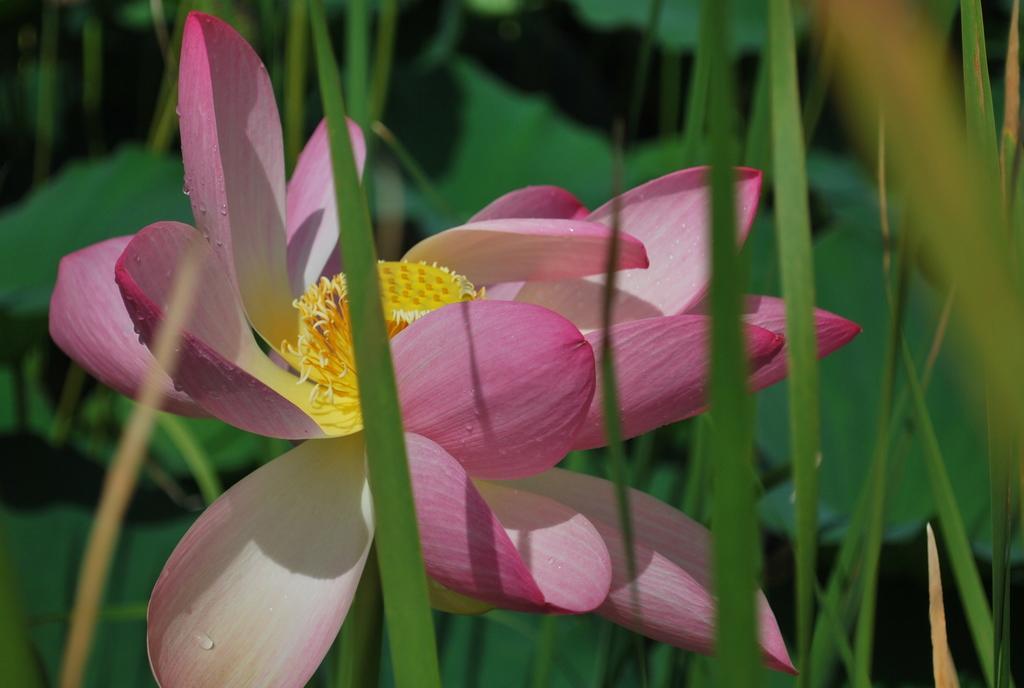Describe this image in one or two sentences. In this picture there is a flower in the image and there is greenery in the background area of the image. 